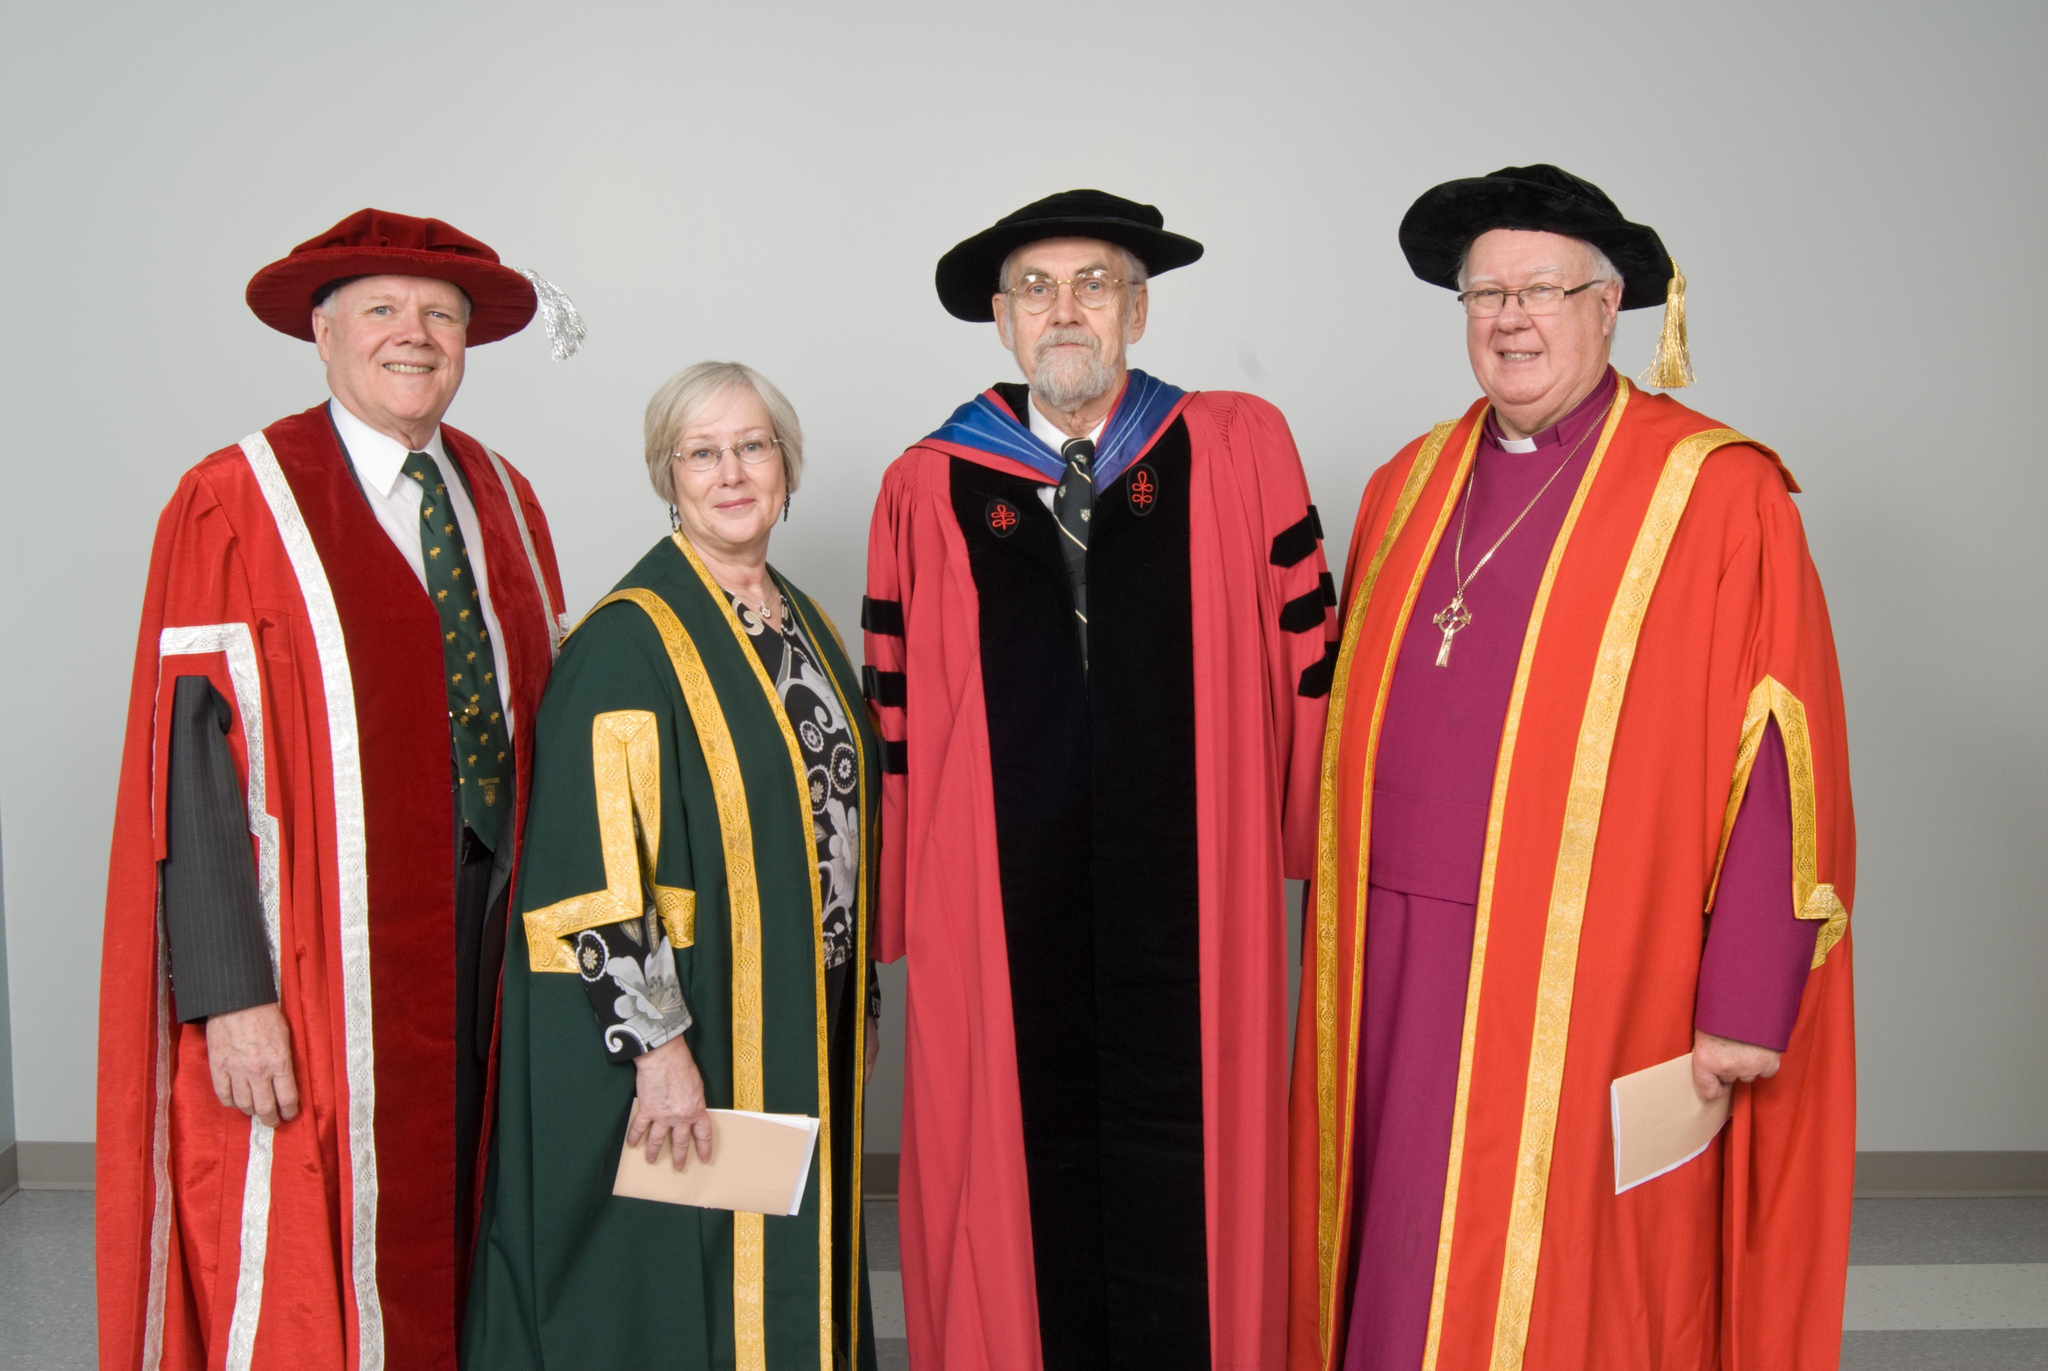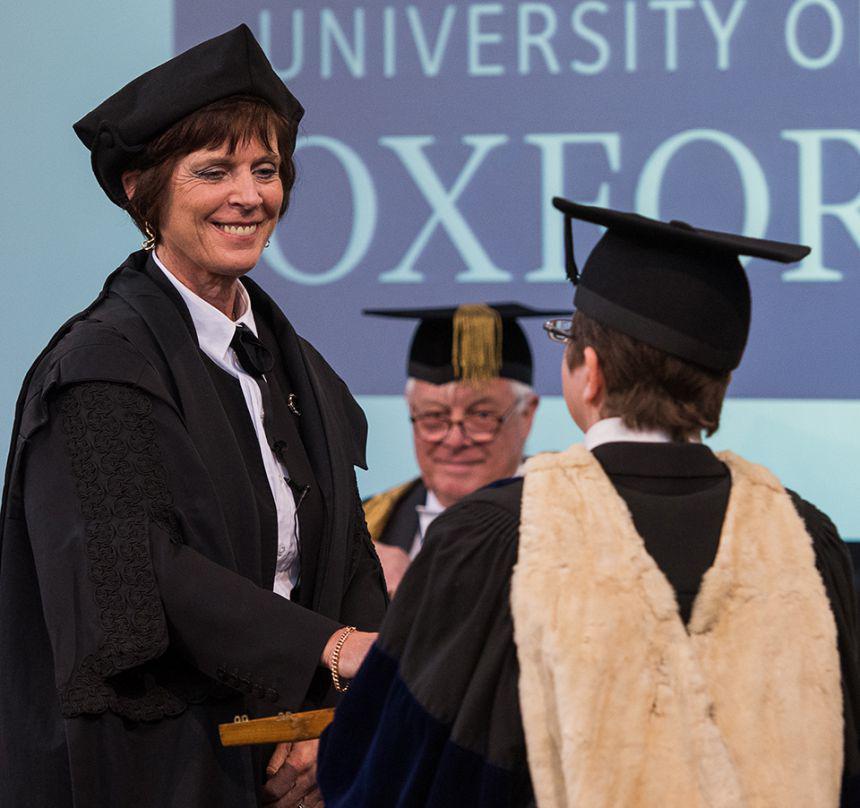The first image is the image on the left, the second image is the image on the right. Evaluate the accuracy of this statement regarding the images: "There are at least eight people in total.". Is it true? Answer yes or no. No. The first image is the image on the left, the second image is the image on the right. Assess this claim about the two images: "The right image contains exactly four humans wearing graduation uniforms.". Correct or not? Answer yes or no. No. 